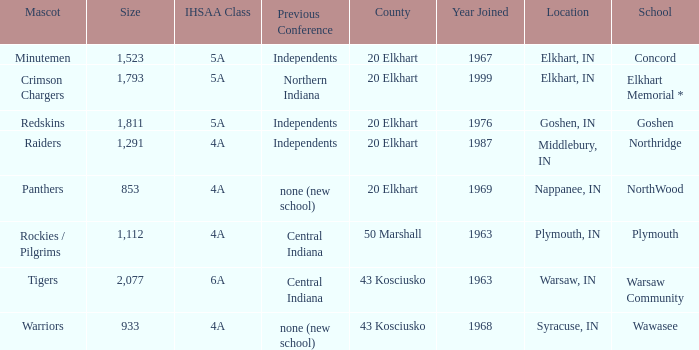What is the size of the team that was previously from Central Indiana conference, and is in IHSSA Class 4a? 1112.0. 